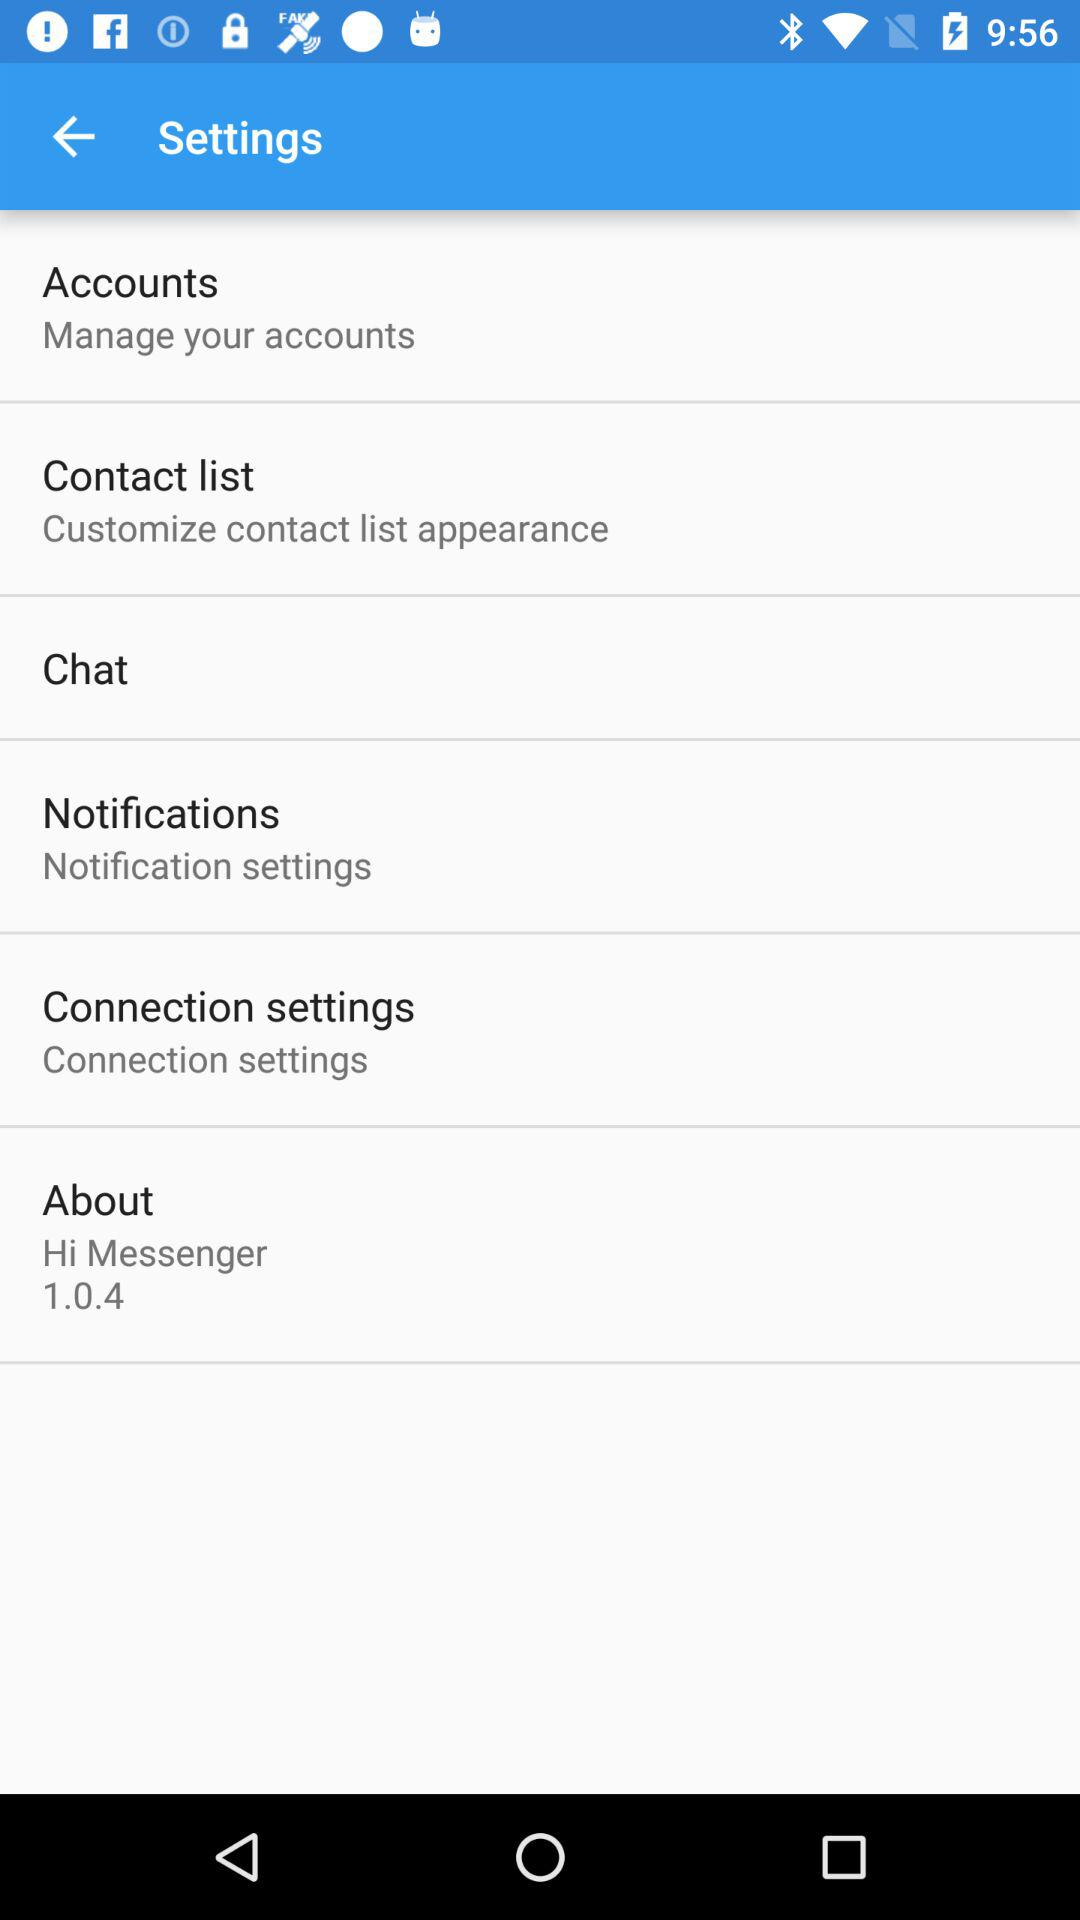What version is shown? The shown version is 1.0.4. 